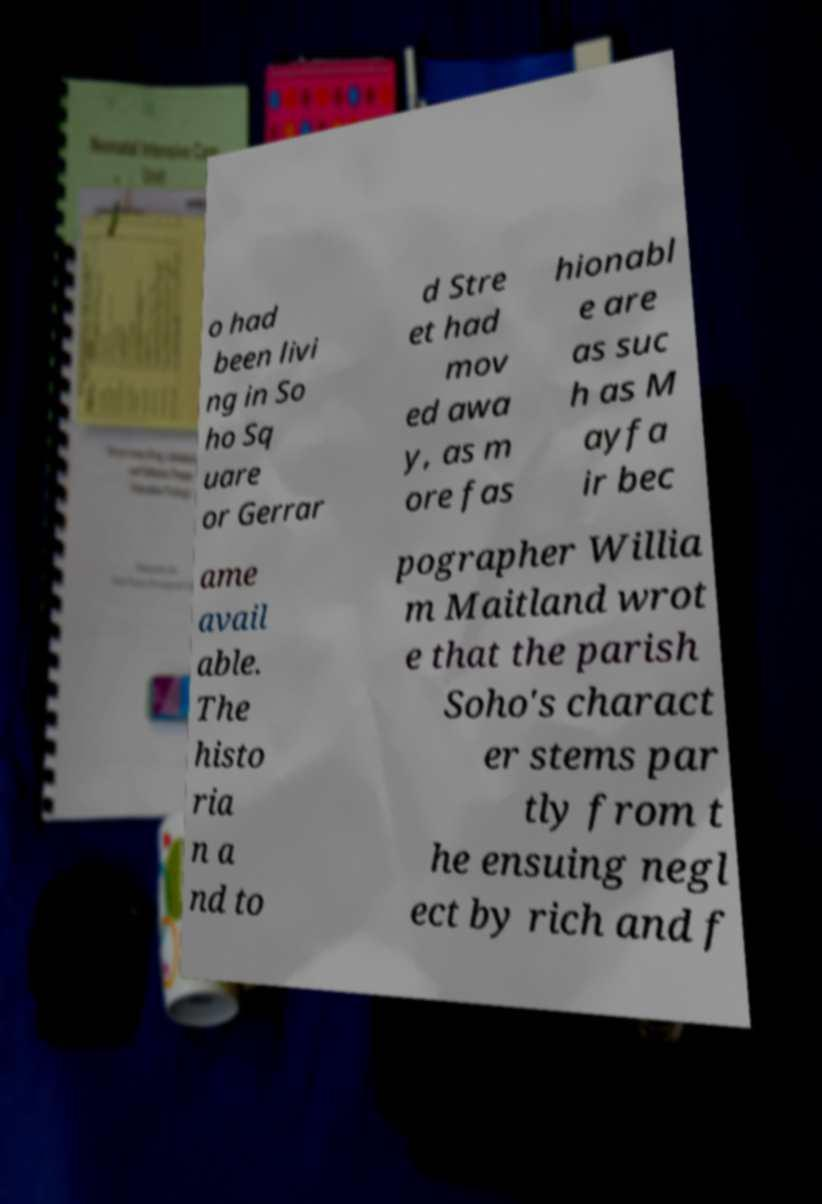Can you accurately transcribe the text from the provided image for me? o had been livi ng in So ho Sq uare or Gerrar d Stre et had mov ed awa y, as m ore fas hionabl e are as suc h as M ayfa ir bec ame avail able. The histo ria n a nd to pographer Willia m Maitland wrot e that the parish Soho's charact er stems par tly from t he ensuing negl ect by rich and f 